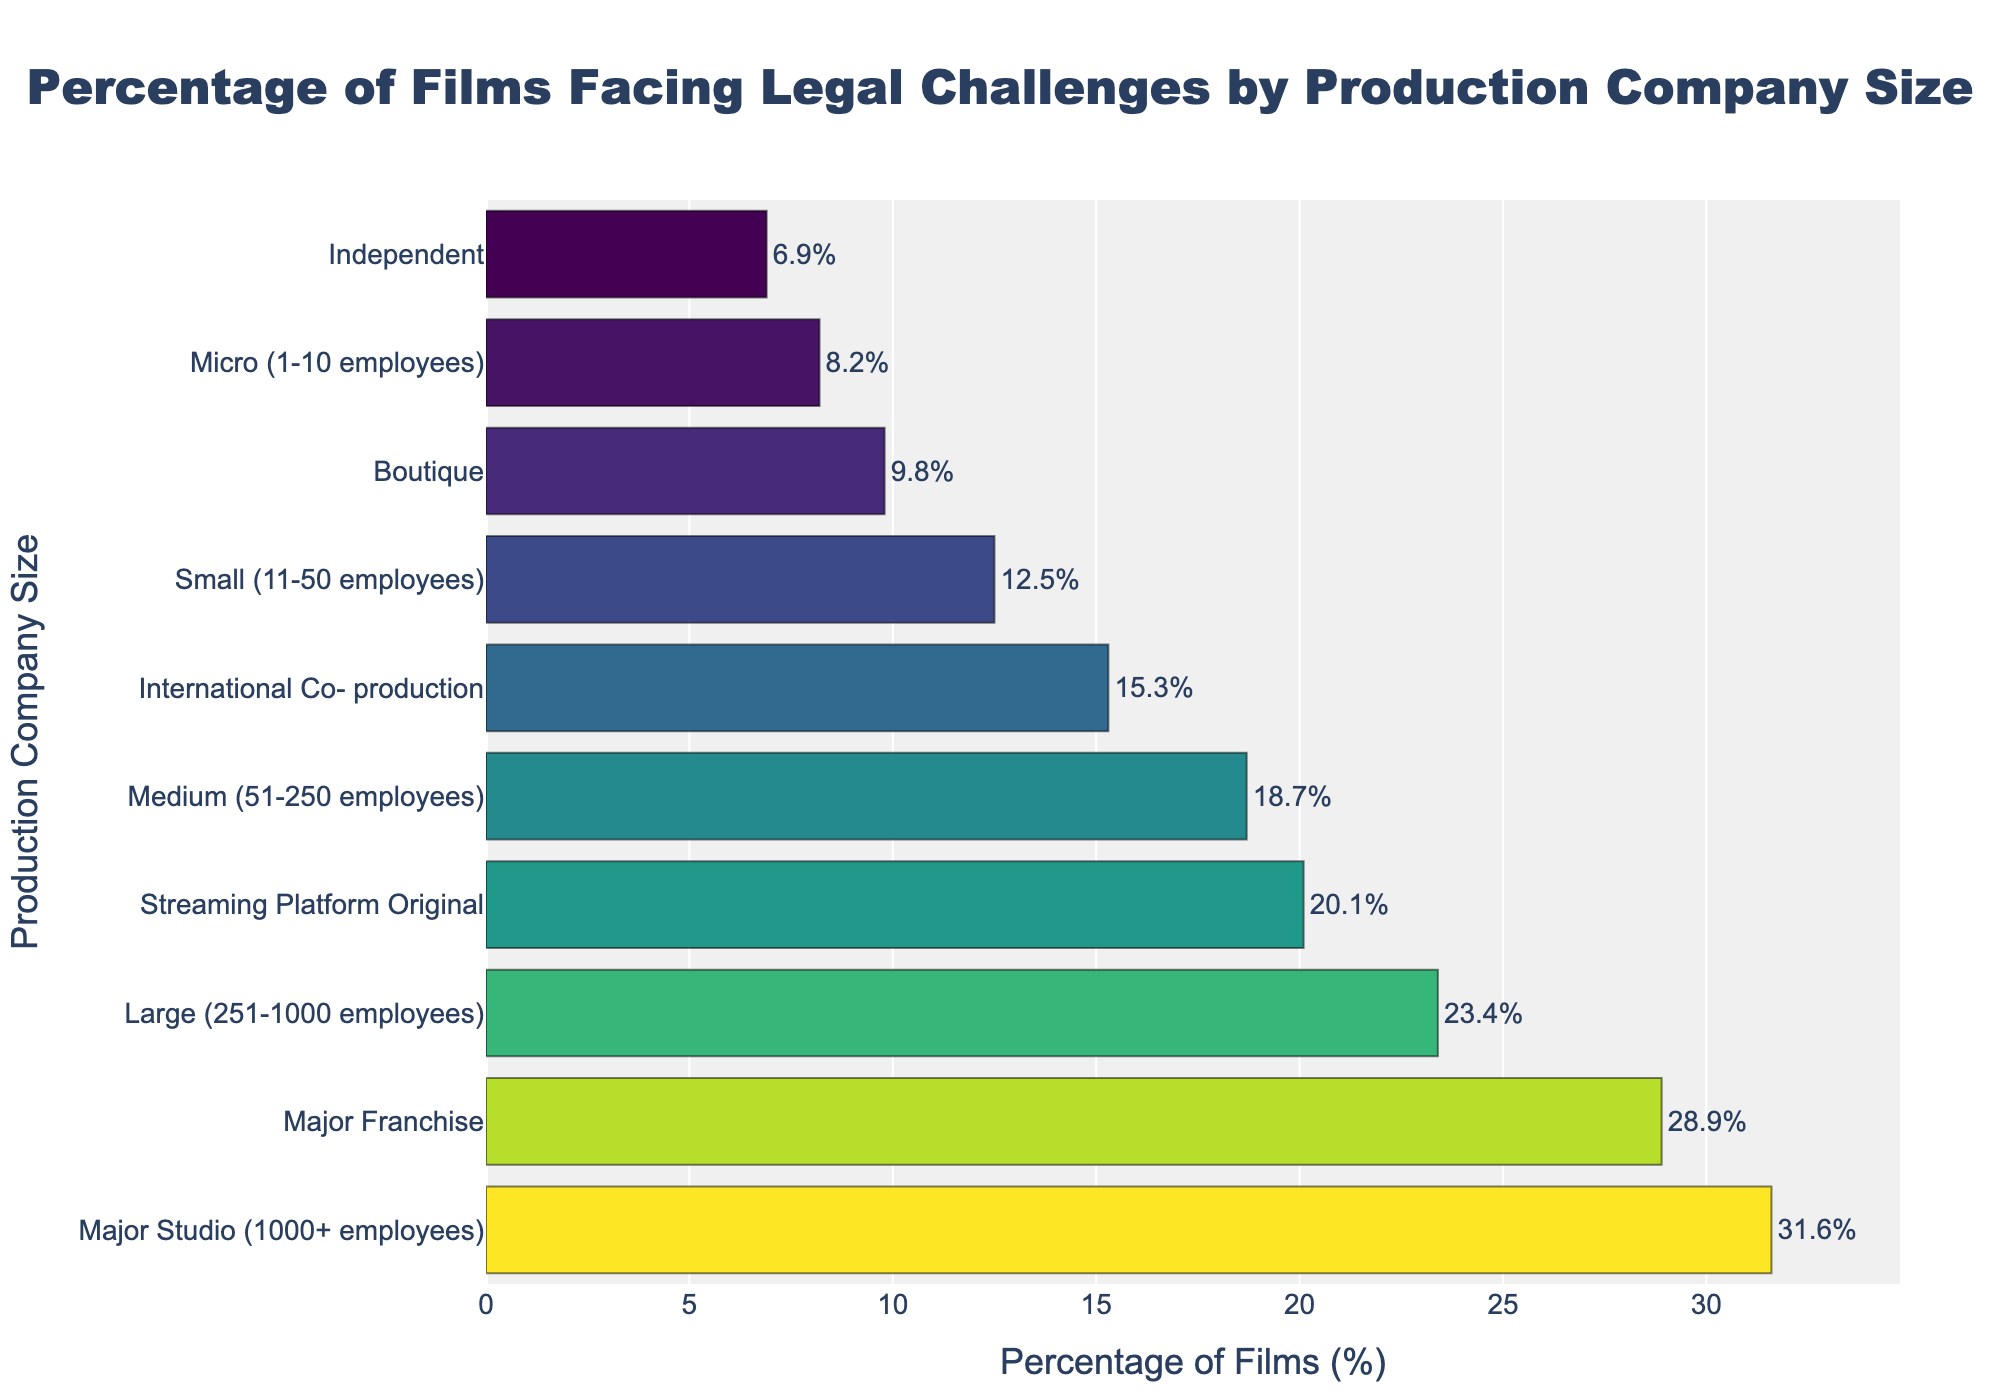Which production company size has the highest percentage of films facing legal challenges? The highest bar represents the "Major Studio" category with a percentage of 31.6, making it the production company size with the highest percentage of films facing legal challenges.
Answer: Major Studio Which production company size has the lowest percentage of films facing legal challenges? The lowest bar represents the "Independent" category with a percentage of 6.9, making it the production company size with the lowest percentage of films facing legal challenges.
Answer: Independent How does the percentage of films facing legal challenges for 'Medium' companies compare to that of 'Streaming Platform Original'? By observing the bar lengths, 'Medium' companies have a percentage of 18.7, and 'Streaming Platform Original' have a percentage of 20.1. Thus, 'Streaming Platform Original' has a slightly higher percentage.
Answer: Streaming Platform Original What is the difference in percentage of films facing legal challenges between 'Large' and 'Micro' production companies? The percentage for 'Large' is 23.4 and for 'Micro' it is 8.2. Subtracting these gives 23.4 - 8.2 = 15.2, so the difference is 15.2%.
Answer: 15.2% What is the combined percentage of films facing legal challenges for 'Boutique' and 'International Co-production' companies? The percentages are 9.8 for 'Boutique' and 15.3 for 'International Co-production'. Adding these gives 9.8 + 15.3 = 25.1.
Answer: 25.1% What is the average percentage of films facing legal challenges among 'Independent', 'Boutique', and 'Micro' companies? The percentages are 6.9 for 'Independent', 9.8 for 'Boutique', and 8.2 for 'Micro'. The sum is 6.9 + 9.8 + 8.2 = 24.9. The average is 24.9/3 = 8.3.
Answer: 8.3 Which category has a slightly higher percentage, 'Major Franchise' or 'Streaming Platform Original'? The percentage for 'Major Franchise' is 28.9 and for 'Streaming Platform Original' it is 20.1. Therefore, 'Major Franchise' has a slightly higher percentage.
Answer: Major Franchise In terms of percentage, how many more films from 'Major Studio' face legal challenges compared to 'Micro' companies? The percentage for 'Major Studio' is 31.6 and for 'Micro' it is 8.2. The difference is 31.6 - 8.2 = 23.4.
Answer: 23.4% What is the median percentage of films facing legal challenges across all production company sizes listed? The percentages listed are: 31.6, 28.9, 23.4, 20.1, 18.7, 15.3, 12.5, 9.8, 8.2, 6.9. These sorted values are: 6.9, 8.2, 9.8, 12.5, 15.3, 18.7, 20.1, 23.4, 28.9, 31.6. The median is the average of 15.3 and 18.7, which is (15.3 + 18.7) / 2 = 17.0.
Answer: 17.0 